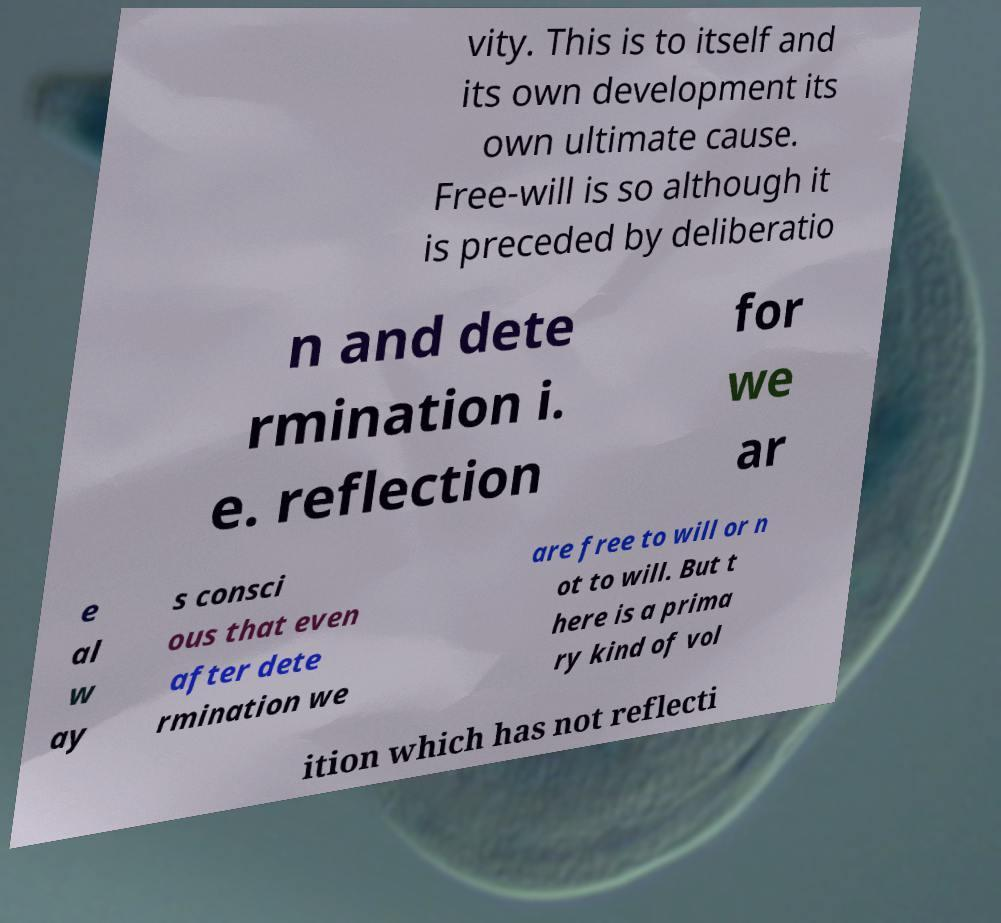For documentation purposes, I need the text within this image transcribed. Could you provide that? vity. This is to itself and its own development its own ultimate cause. Free-will is so although it is preceded by deliberatio n and dete rmination i. e. reflection for we ar e al w ay s consci ous that even after dete rmination we are free to will or n ot to will. But t here is a prima ry kind of vol ition which has not reflecti 